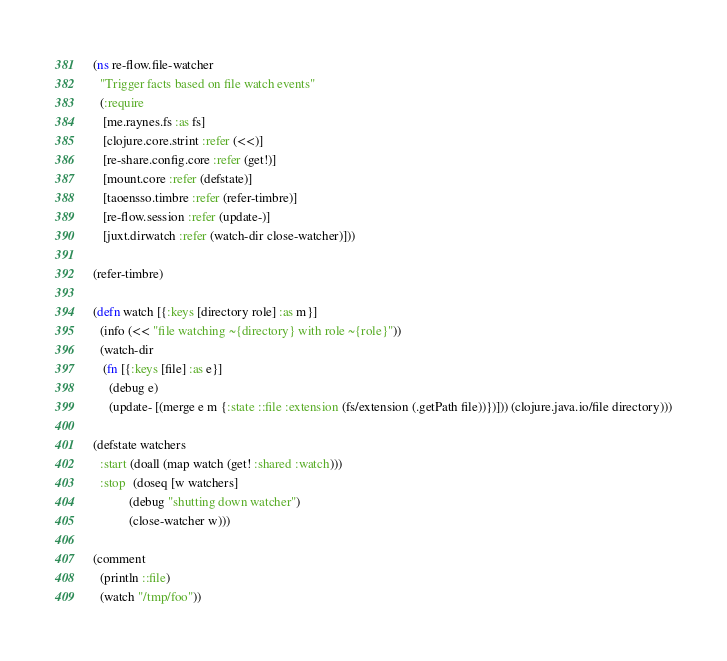<code> <loc_0><loc_0><loc_500><loc_500><_Clojure_>(ns re-flow.file-watcher
  "Trigger facts based on file watch events"
  (:require
   [me.raynes.fs :as fs]
   [clojure.core.strint :refer (<<)]
   [re-share.config.core :refer (get!)]
   [mount.core :refer (defstate)]
   [taoensso.timbre :refer (refer-timbre)]
   [re-flow.session :refer (update-)]
   [juxt.dirwatch :refer (watch-dir close-watcher)]))

(refer-timbre)

(defn watch [{:keys [directory role] :as m}]
  (info (<< "file watching ~{directory} with role ~{role}"))
  (watch-dir
   (fn [{:keys [file] :as e}]
     (debug e)
     (update- [(merge e m {:state ::file :extension (fs/extension (.getPath file))})])) (clojure.java.io/file directory)))

(defstate watchers
  :start (doall (map watch (get! :shared :watch)))
  :stop  (doseq [w watchers]
           (debug "shutting down watcher")
           (close-watcher w)))

(comment
  (println ::file)
  (watch "/tmp/foo"))
</code> 